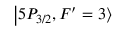<formula> <loc_0><loc_0><loc_500><loc_500>\left | 5 P _ { 3 / 2 } , F ^ { \prime } = 3 \right \rangle</formula> 